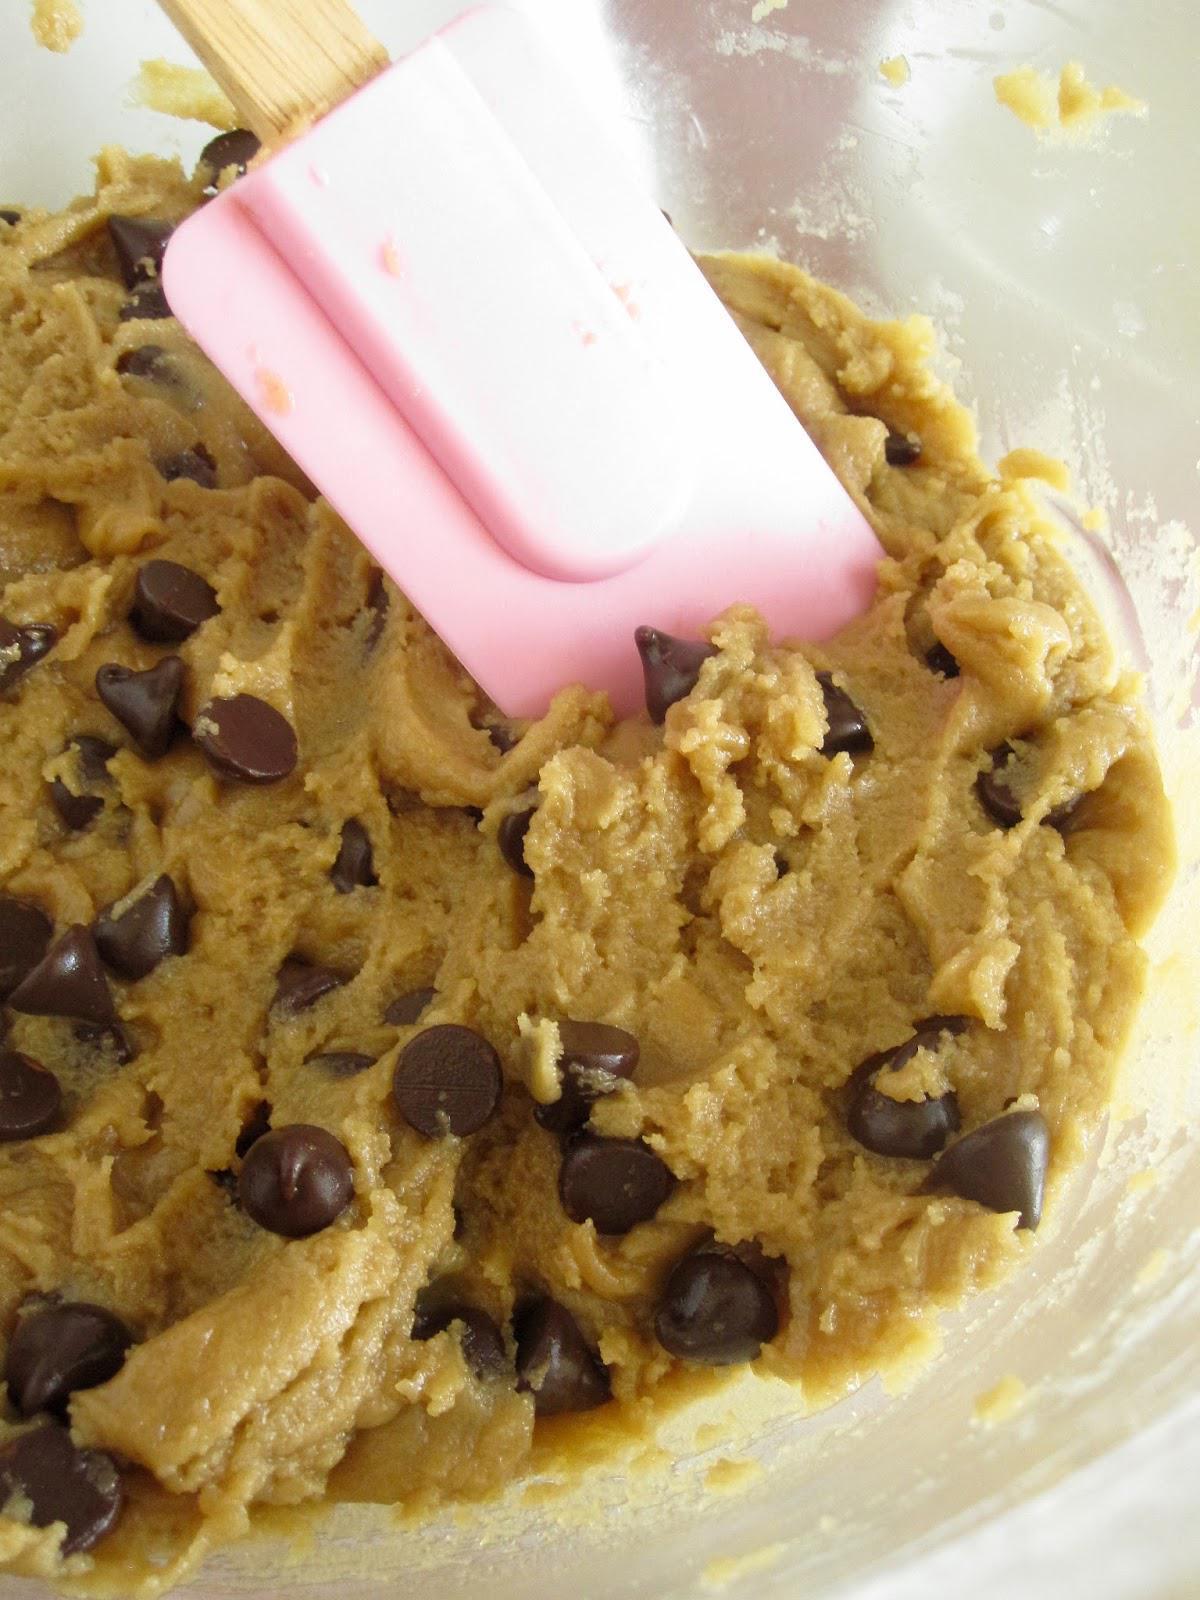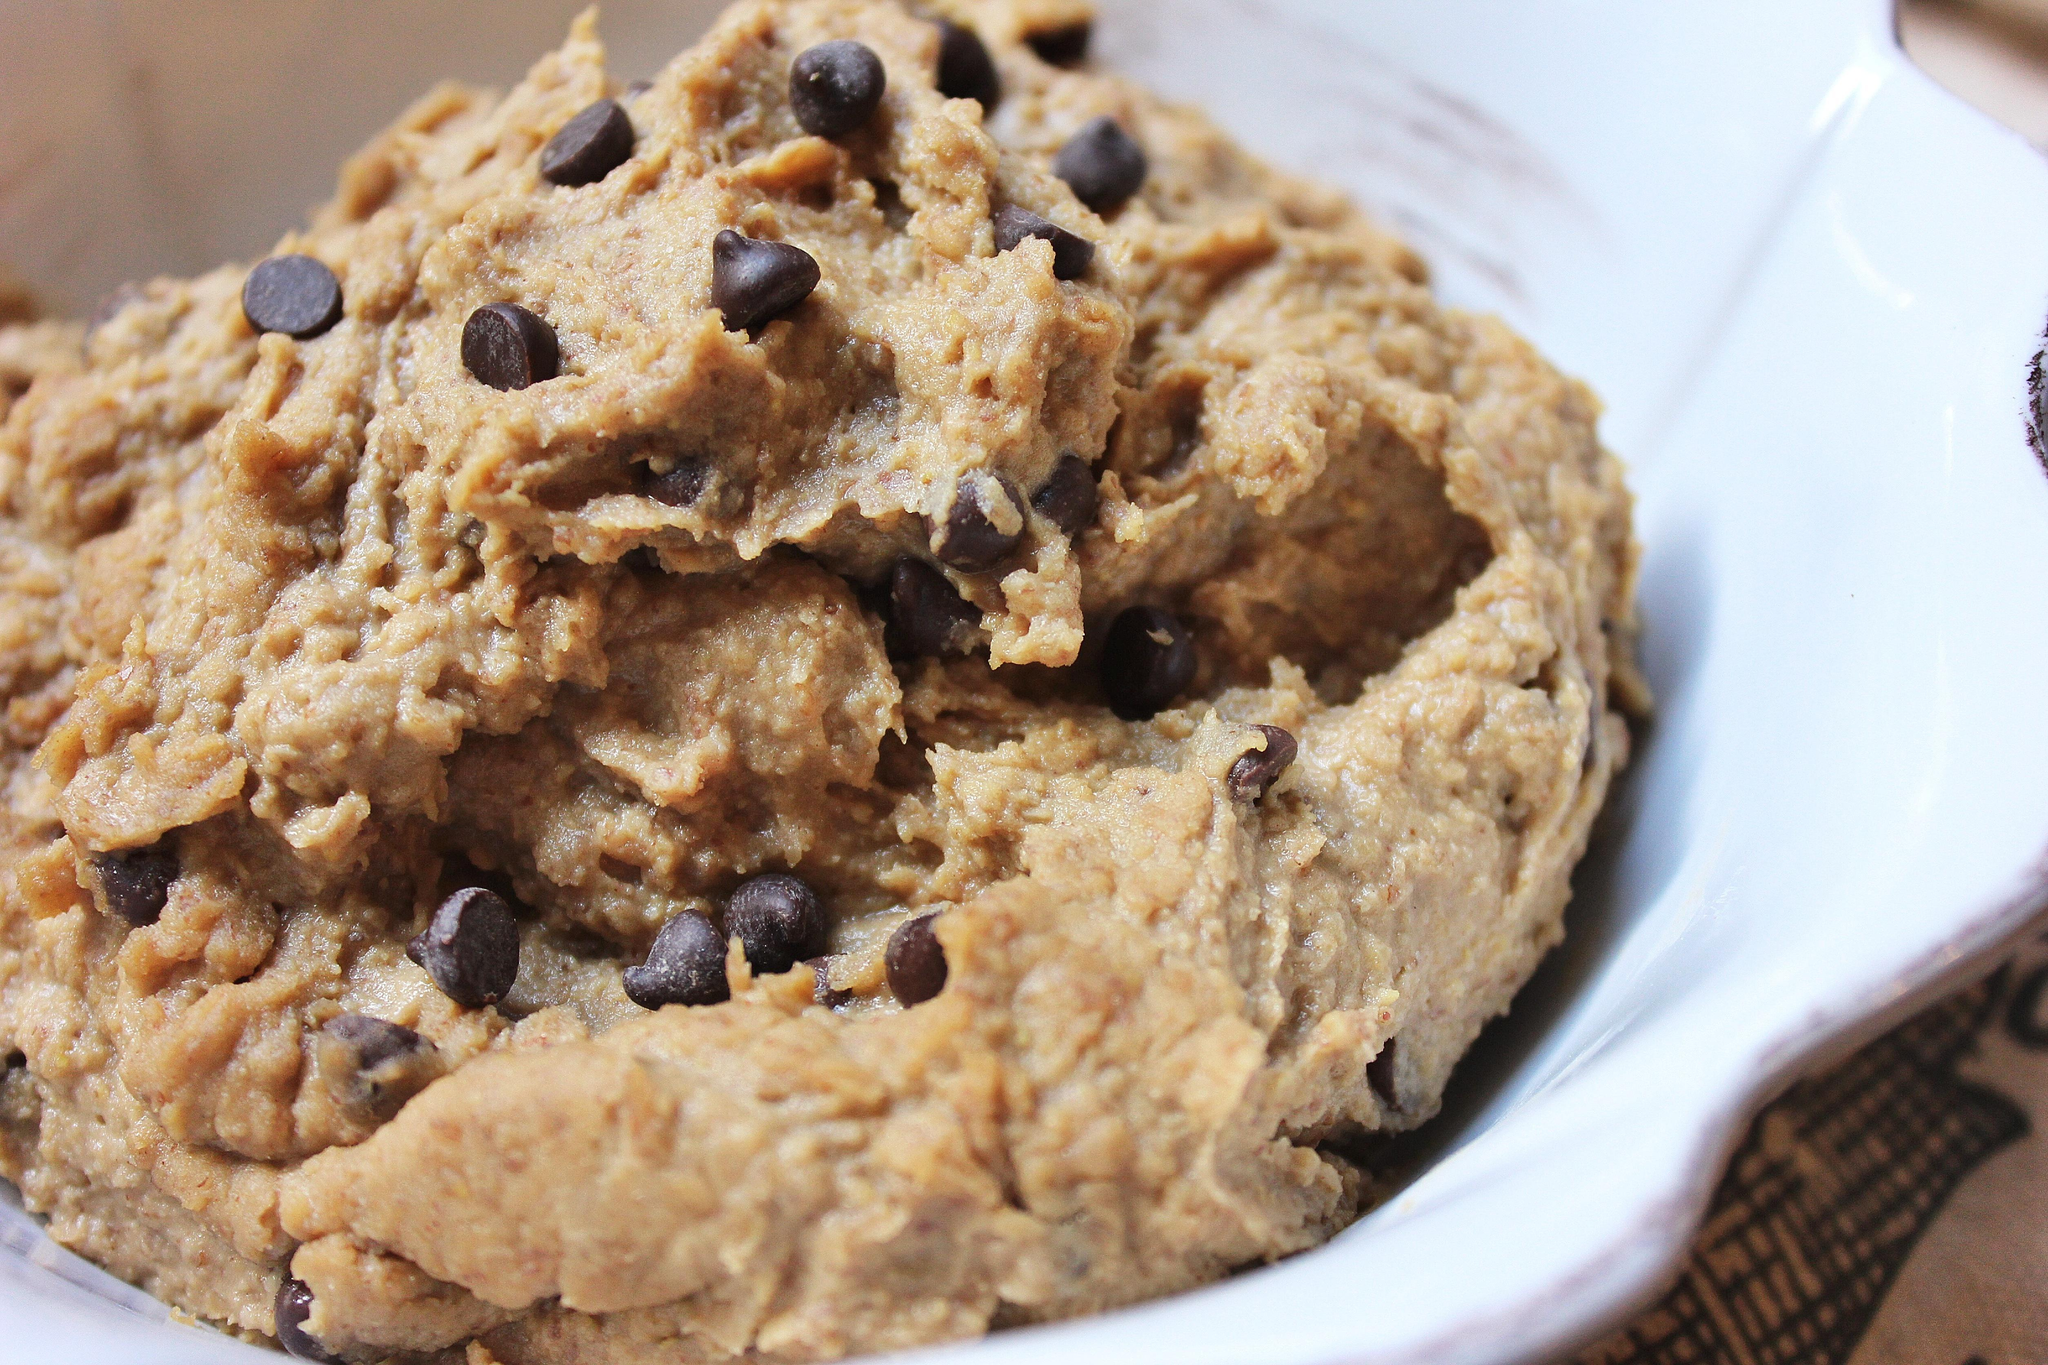The first image is the image on the left, the second image is the image on the right. Considering the images on both sides, is "Some of the cookie dough is in balls neatly lined up." valid? Answer yes or no. No. The first image is the image on the left, the second image is the image on the right. Given the left and right images, does the statement "A utensil with a handle is touching raw chocolate chip cookie dough in at least one image." hold true? Answer yes or no. Yes. 